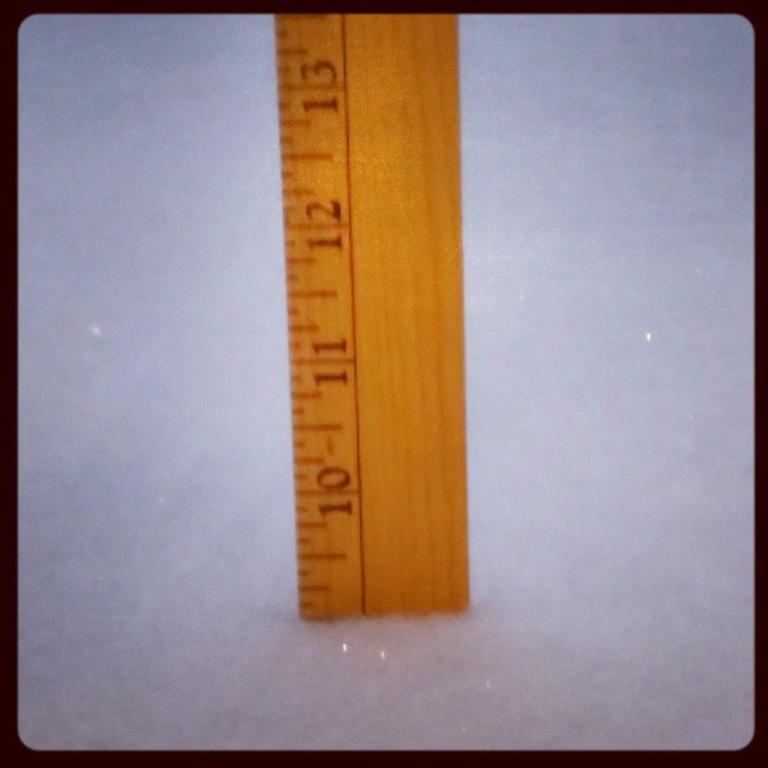<image>
Present a compact description of the photo's key features. The bottom half of a wooden ruler with thirteen at the top 